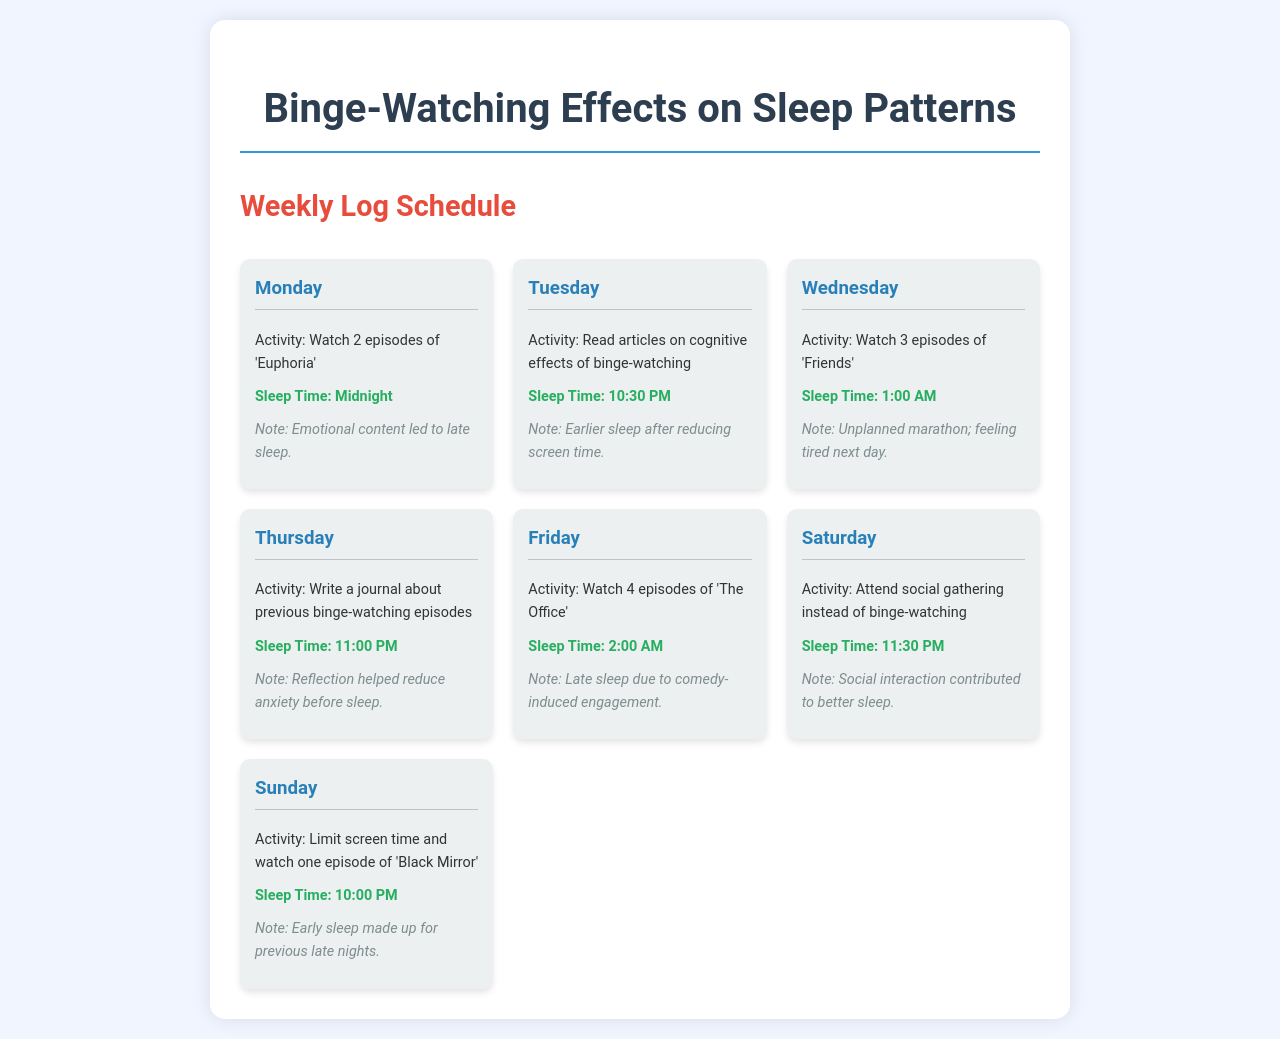What did the participant watch on Monday? The document states that the participant watched 2 episodes of 'Euphoria' on Monday.
Answer: 2 episodes of 'Euphoria' What was the sleep time on Tuesday? The schedule indicates the participant's sleep time was 10:30 PM on Tuesday.
Answer: 10:30 PM Which activity led to late sleep on Friday? The document mentions that late sleep on Friday was due to watching 4 episodes of 'The Office'.
Answer: 4 episodes of 'The Office' What was the main reflection activity on Thursday? The document describes that the participant wrote a journal about previous binge-watching episodes on Thursday.
Answer: Write a journal What was the participant's sleep time on Sunday? According to the schedule, the participant's sleep time on Sunday was 10:00 PM.
Answer: 10:00 PM What was the participant's activity on Saturday instead of binge-watching? The document states that the participant attended a social gathering on Saturday instead of binge-watching.
Answer: Social gathering How did the content watched on Monday affect sleep? The note regarding Monday indicates that the emotional content led to late sleep.
Answer: Emotional content Which day involved limiting screen time? The document indicates that limiting screen time occurred on Sunday.
Answer: Sunday On which day did the participant feel tired the next day? The schedule mentions that feeling tired the next day occurred after an unplanned marathon on Wednesday.
Answer: Wednesday 